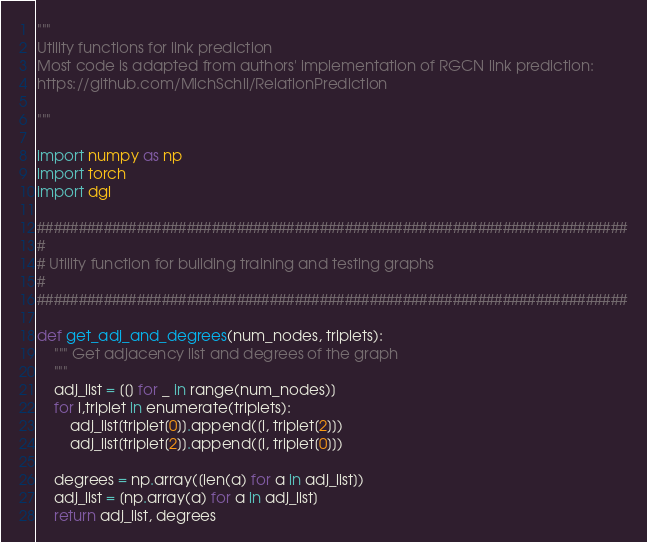<code> <loc_0><loc_0><loc_500><loc_500><_Python_>"""
Utility functions for link prediction
Most code is adapted from authors' implementation of RGCN link prediction:
https://github.com/MichSchli/RelationPrediction

"""

import numpy as np
import torch
import dgl

#######################################################################
#
# Utility function for building training and testing graphs
#
#######################################################################

def get_adj_and_degrees(num_nodes, triplets):
    """ Get adjacency list and degrees of the graph
    """
    adj_list = [[] for _ in range(num_nodes)]
    for i,triplet in enumerate(triplets):
        adj_list[triplet[0]].append([i, triplet[2]])
        adj_list[triplet[2]].append([i, triplet[0]])

    degrees = np.array([len(a) for a in adj_list])
    adj_list = [np.array(a) for a in adj_list]
    return adj_list, degrees
</code> 